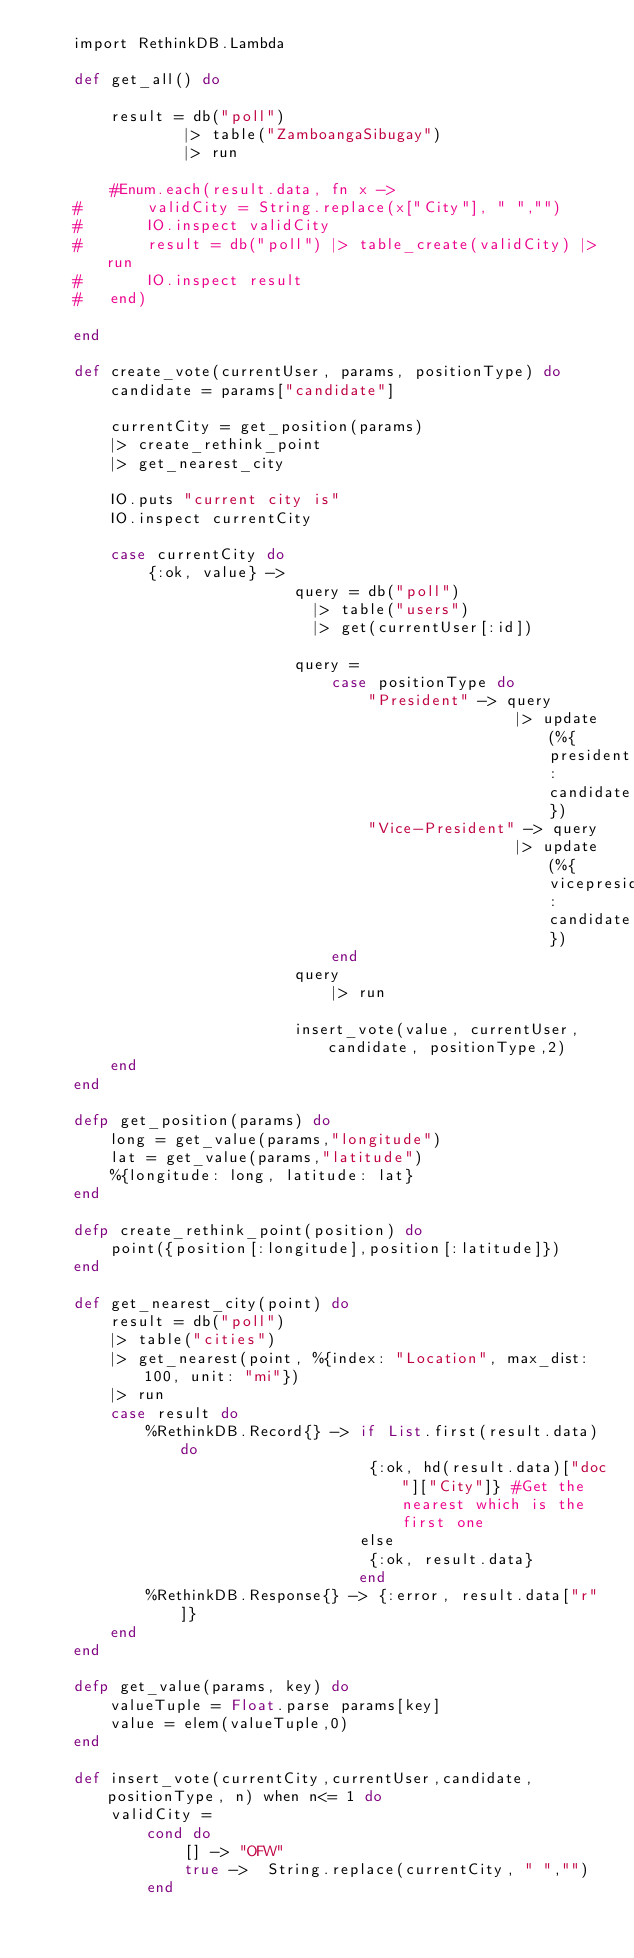Convert code to text. <code><loc_0><loc_0><loc_500><loc_500><_Elixir_>  	import RethinkDB.Lambda

  	def get_all() do

  		result = db("poll") 
			  	|> table("ZamboangaSibugay") 
			    |> run

		#Enum.each(result.data, fn x -> 
	#		validCity = String.replace(x["City"], " ","")
	#		IO.inspect validCity
	#		result = db("poll") |> table_create(validCity) |> run 
	#		IO.inspect result
	#	end)

  	end

	def create_vote(currentUser, params, positionType) do
	    candidate = params["candidate"] 

	    currentCity = get_position(params)
	    |> create_rethink_point
	    |> get_nearest_city

    	IO.puts "current city is" 
    	IO.inspect currentCity

    	case currentCity do
    		{:ok, value} ->
			    			query = db("poll") 
						      |> table("users")
						      |> get(currentUser[:id])

						    query = 
						    	case positionType do 
							    	"President" -> query 
							      					|> update(%{president: candidate})
			      					"Vice-President" -> query 
							      					|> update(%{vicepresident: candidate})  
						      	end
					      	query 
						    	|> run

					      	insert_vote(value, currentUser, candidate, positionType,2)
    	end
	end

	defp get_position(params) do
	    long = get_value(params,"longitude")
	    lat = get_value(params,"latitude")
		%{longitude: long, latitude: lat}
	end

	defp create_rethink_point(position) do
		point({position[:longitude],position[:latitude]})
	end

	def get_nearest_city(point) do
		result = db("poll") 
	    |> table("cities") 
	    |> get_nearest(point, %{index: "Location", max_dist: 100, unit: "mi"})
	    |> run
	    case result do
	    	%RethinkDB.Record{} -> if List.first(result.data) do
      								{:ok, hd(result.data)["doc"]["City"]} #Get the nearest which is the first one
								   else 
									{:ok, result.data}
      							   end
	    	%RethinkDB.Response{} -> {:error, result.data["r"]}
	    end
	end

	defp get_value(params, key) do
		valueTuple = Float.parse params[key] 
    	value = elem(valueTuple,0)
	end

	def insert_vote(currentCity,currentUser,candidate, positionType, n) when n<= 1 do
		validCity = 
			cond do
				[] -> "OFW"
				true ->  String.replace(currentCity, " ","")
			end
		</code> 